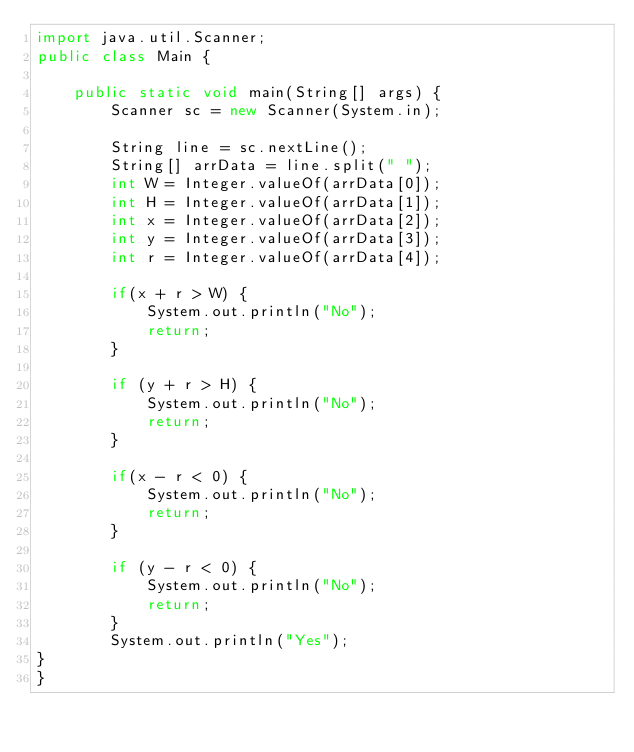<code> <loc_0><loc_0><loc_500><loc_500><_Java_>import java.util.Scanner;
public class Main {

    public static void main(String[] args) {
        Scanner sc = new Scanner(System.in);

        String line = sc.nextLine();
        String[] arrData = line.split(" ");
        int W = Integer.valueOf(arrData[0]);
        int H = Integer.valueOf(arrData[1]);
        int x = Integer.valueOf(arrData[2]);
        int y = Integer.valueOf(arrData[3]);
        int r = Integer.valueOf(arrData[4]);

        if(x + r > W) {
            System.out.println("No");
            return;
        }

        if (y + r > H) {
            System.out.println("No");
            return;
        }

        if(x - r < 0) {
            System.out.println("No");
            return;
        }

        if (y - r < 0) {
            System.out.println("No");
            return;
        }
        System.out.println("Yes");
}
}
</code> 